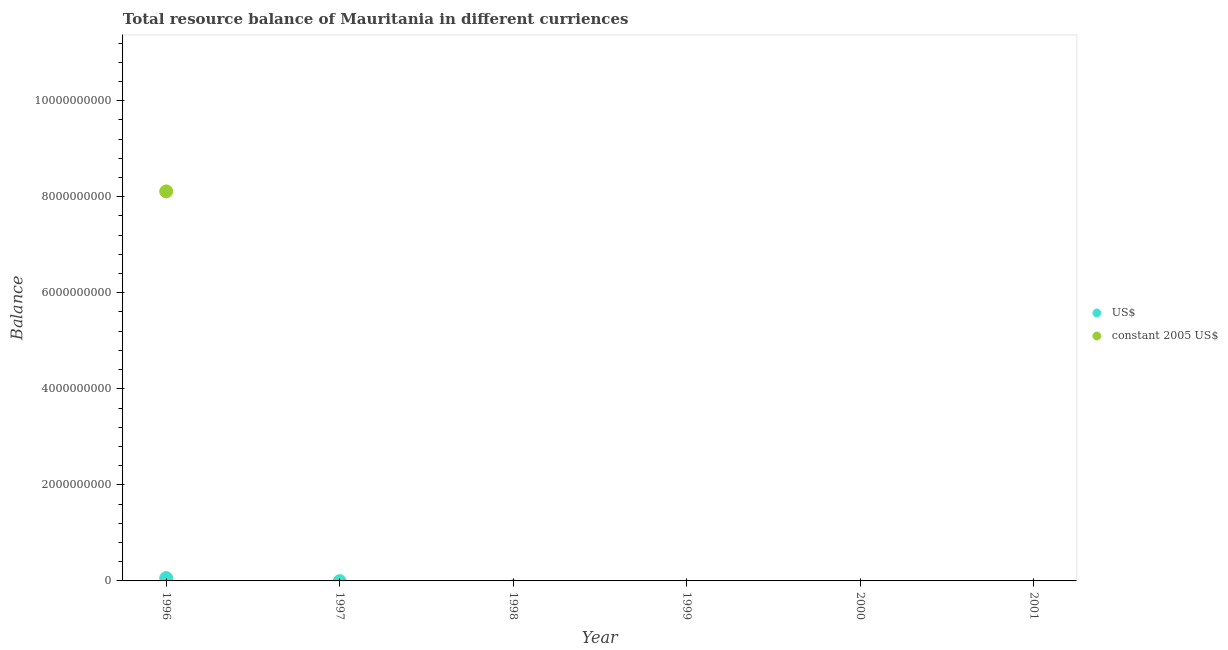How many different coloured dotlines are there?
Keep it short and to the point. 2. Is the number of dotlines equal to the number of legend labels?
Provide a succinct answer. No. Across all years, what is the maximum resource balance in constant us$?
Offer a very short reply. 8.11e+09. What is the total resource balance in constant us$ in the graph?
Offer a terse response. 8.11e+09. What is the difference between the resource balance in us$ in 1997 and the resource balance in constant us$ in 2001?
Give a very brief answer. 0. What is the average resource balance in us$ per year?
Provide a short and direct response. 9.85e+06. In the year 1996, what is the difference between the resource balance in constant us$ and resource balance in us$?
Offer a very short reply. 8.05e+09. What is the difference between the highest and the lowest resource balance in constant us$?
Ensure brevity in your answer.  8.11e+09. Does the resource balance in constant us$ monotonically increase over the years?
Keep it short and to the point. No. Is the resource balance in us$ strictly greater than the resource balance in constant us$ over the years?
Provide a succinct answer. No. What is the difference between two consecutive major ticks on the Y-axis?
Give a very brief answer. 2.00e+09. Are the values on the major ticks of Y-axis written in scientific E-notation?
Offer a very short reply. No. Does the graph contain grids?
Provide a short and direct response. No. How are the legend labels stacked?
Offer a terse response. Vertical. What is the title of the graph?
Keep it short and to the point. Total resource balance of Mauritania in different curriences. Does "Grants" appear as one of the legend labels in the graph?
Provide a succinct answer. No. What is the label or title of the X-axis?
Ensure brevity in your answer.  Year. What is the label or title of the Y-axis?
Keep it short and to the point. Balance. What is the Balance of US$ in 1996?
Give a very brief answer. 5.91e+07. What is the Balance of constant 2005 US$ in 1996?
Your response must be concise. 8.11e+09. What is the Balance of US$ in 1998?
Provide a succinct answer. 0. What is the Balance in constant 2005 US$ in 1998?
Ensure brevity in your answer.  0. What is the Balance of US$ in 1999?
Make the answer very short. 0. What is the Balance of constant 2005 US$ in 1999?
Keep it short and to the point. 0. What is the Balance in US$ in 2000?
Give a very brief answer. 0. What is the Balance of constant 2005 US$ in 2000?
Offer a very short reply. 0. What is the Balance in constant 2005 US$ in 2001?
Ensure brevity in your answer.  0. Across all years, what is the maximum Balance in US$?
Make the answer very short. 5.91e+07. Across all years, what is the maximum Balance in constant 2005 US$?
Provide a succinct answer. 8.11e+09. What is the total Balance of US$ in the graph?
Your answer should be compact. 5.91e+07. What is the total Balance of constant 2005 US$ in the graph?
Offer a terse response. 8.11e+09. What is the average Balance in US$ per year?
Provide a succinct answer. 9.85e+06. What is the average Balance of constant 2005 US$ per year?
Your answer should be very brief. 1.35e+09. In the year 1996, what is the difference between the Balance in US$ and Balance in constant 2005 US$?
Keep it short and to the point. -8.05e+09. What is the difference between the highest and the lowest Balance of US$?
Ensure brevity in your answer.  5.91e+07. What is the difference between the highest and the lowest Balance in constant 2005 US$?
Make the answer very short. 8.11e+09. 